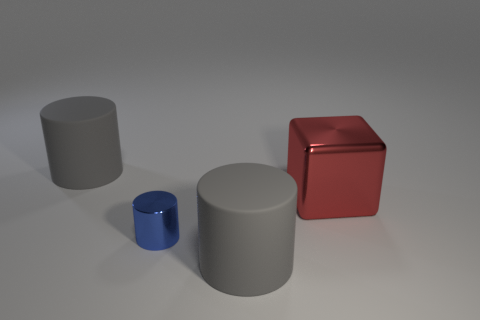Add 2 tiny shiny cylinders. How many objects exist? 6 Subtract all cubes. How many objects are left? 3 Add 1 big red shiny things. How many big red shiny things exist? 2 Subtract 0 brown cubes. How many objects are left? 4 Subtract all red blocks. Subtract all large matte things. How many objects are left? 1 Add 2 red metallic things. How many red metallic things are left? 3 